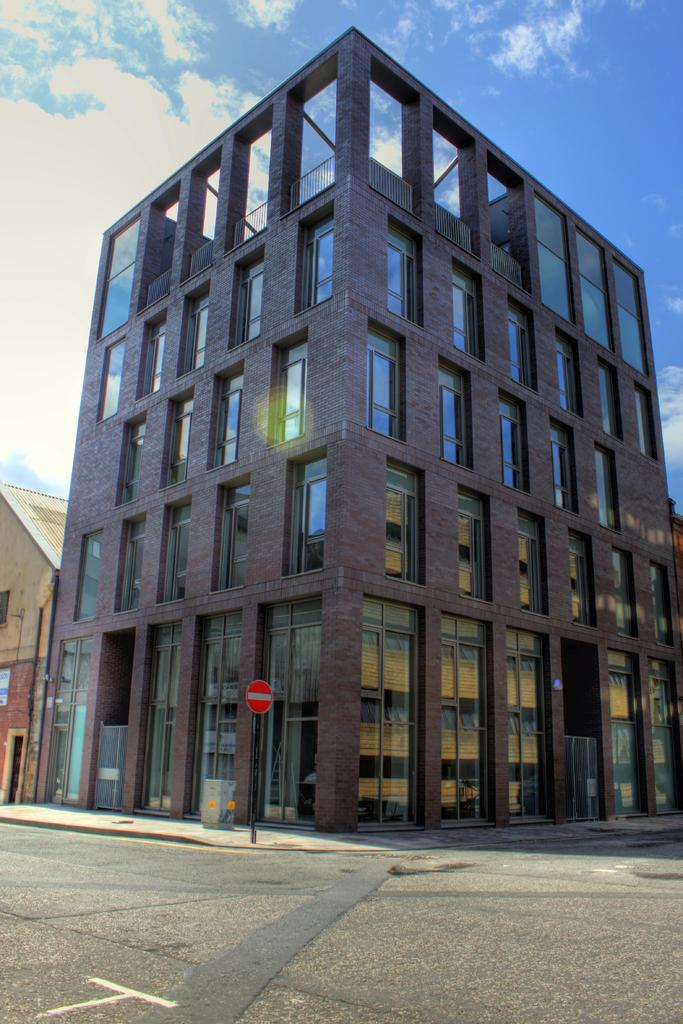What is the main feature of the image? There is a road in the image. What else can be seen attached to a pole in the image? There is a board attached to a pole in the image. What type of structures are visible in the image? There are buildings in the image. Can you describe the object in the image? The object in the image is not specified, but it could be a sign, a vehicle, or any other object. What is visible in the background of the image? The sky is visible in the background of the image. What can be observed in the sky? Clouds are present in the sky. What type of produce is being harvested in the image? There is no produce or harvesting activity visible in the image. How long does it take for the cattle to cross the road in the image? There are no cattle present in the image, so it is not possible to determine how long it would take for them to cross the road. 